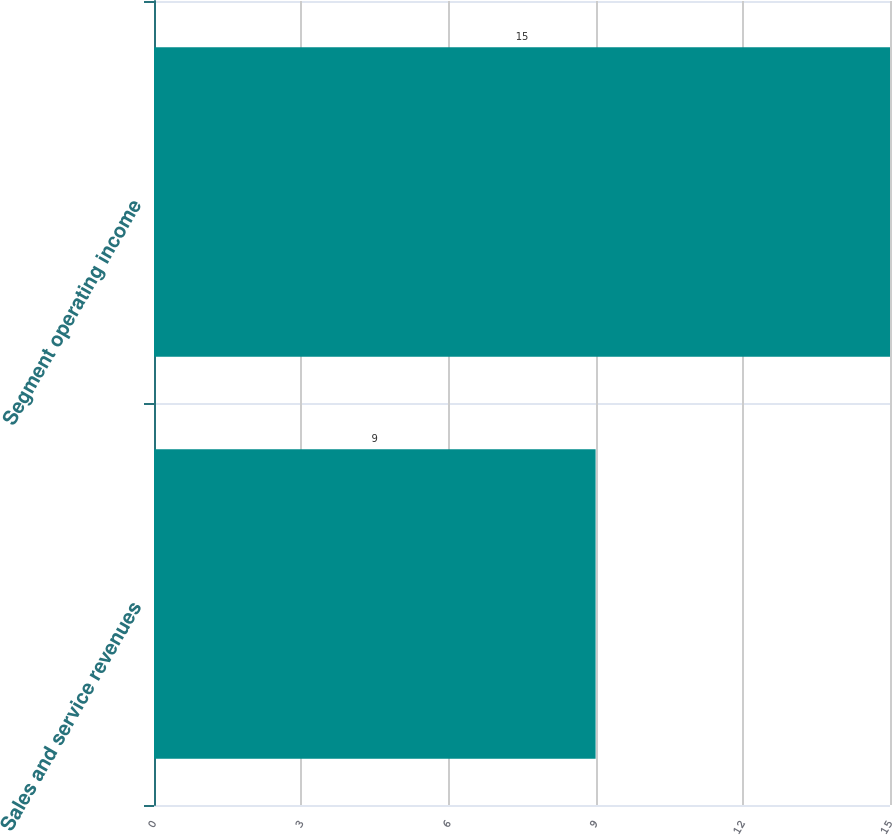Convert chart to OTSL. <chart><loc_0><loc_0><loc_500><loc_500><bar_chart><fcel>Sales and service revenues<fcel>Segment operating income<nl><fcel>9<fcel>15<nl></chart> 